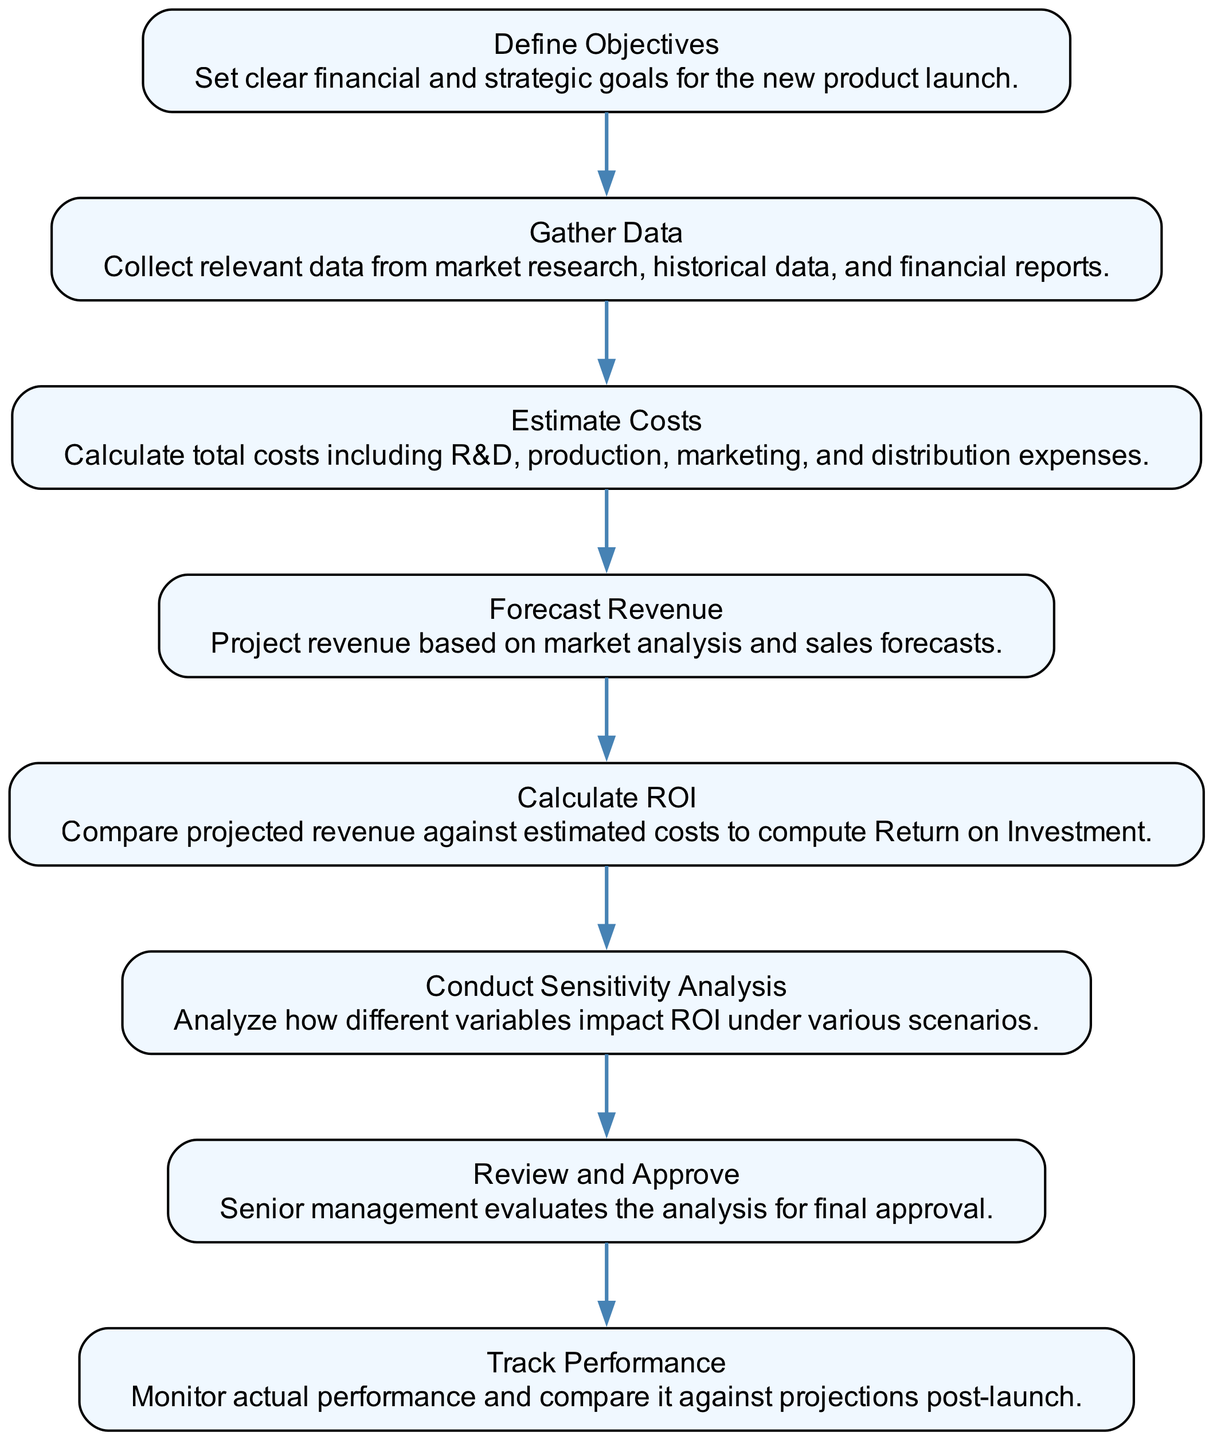What is the first step in the process? The flow chart indicates that the first step is "Define Objectives," which sets the stage for the entire analysis by establishing clear financial and strategic goals.
Answer: Define Objectives How many total nodes are in the diagram? By counting each of the steps listed in the flow chart, we find that there are eight nodes representing distinct stages of the internal ROI analysis process.
Answer: Eight What comes after "Estimate Costs"? The flow chart shows that "Forecast Revenue" is the next step that follows after "Estimate Costs," indicating the logical progression in the analysis.
Answer: Forecast Revenue What is the purpose of "Conduct Sensitivity Analysis"? "Conduct Sensitivity Analysis" serves to analyze how variations in key variables impact the calculated ROI, allowing the team to understand potential outcomes better.
Answer: Analyze impacts Which node leads directly to "Track Performance"? The flow chart signifies that "Review and Approve" directly leads to "Track Performance," showing the flow from the approval stage to the monitoring stage after launch.
Answer: Review and Approve What is the last step in the process? The final node in the flow chart is "Track Performance," indicating that the analysis continues by monitoring the actual performance against projections post-launch.
Answer: Track Performance Which step involves comparing projected revenue and estimated costs? "Calculate ROI" is the step where projected revenue is compared with estimated costs to compute the return on investment, as indicated in the diagram.
Answer: Calculate ROI What type of data is collected during "Gather Data"? During "Gather Data," relevant data is collected from market research, historical data, and financial reports, highlighting the importance of information gathering for analysis.
Answer: Market research, historical data, financial reports What is the purpose of the "Review and Approve" stage? The purpose of the "Review and Approve" stage is for senior management to evaluate the internal ROI analysis for final approval, ensuring that the analysis aligns with the company's goals.
Answer: Evaluate analysis for approval 